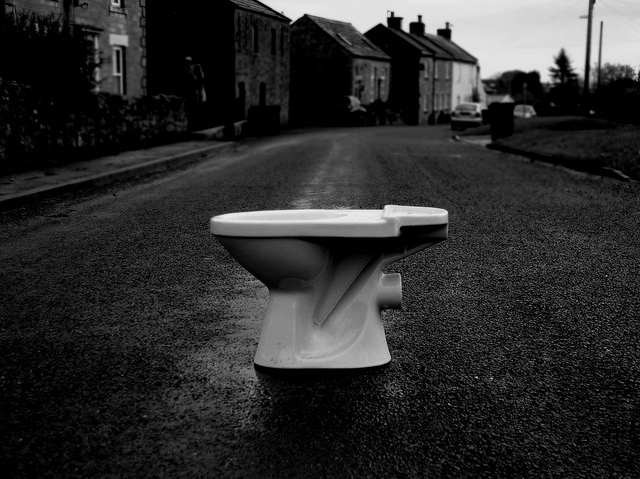<image>What type of zone is this toilet parked in? It is unsure what type of zone the toilet is parked in. It could be a housing, residential, or street zone. What type of zone is this toilet parked in? I am not sure what type of zone this toilet is parked in. It could be a housing zone, residential zone, residential street, or roadway. 